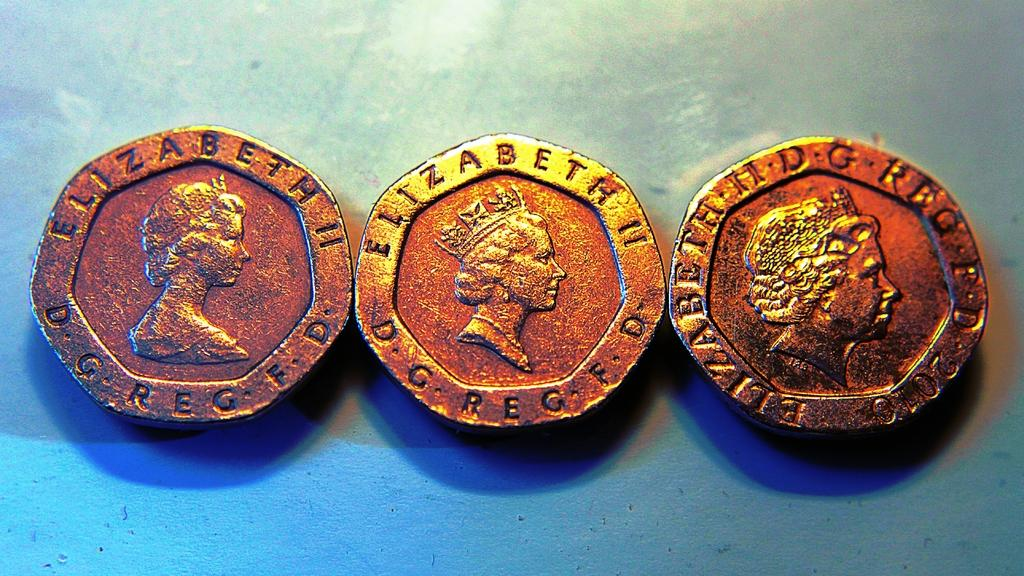<image>
Create a compact narrative representing the image presented. Antique coins embellished with the name Elizabeth II lay next to each other 